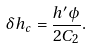Convert formula to latex. <formula><loc_0><loc_0><loc_500><loc_500>\delta h _ { c } = \frac { h ^ { \prime } \phi } { 2 C _ { 2 } } .</formula> 